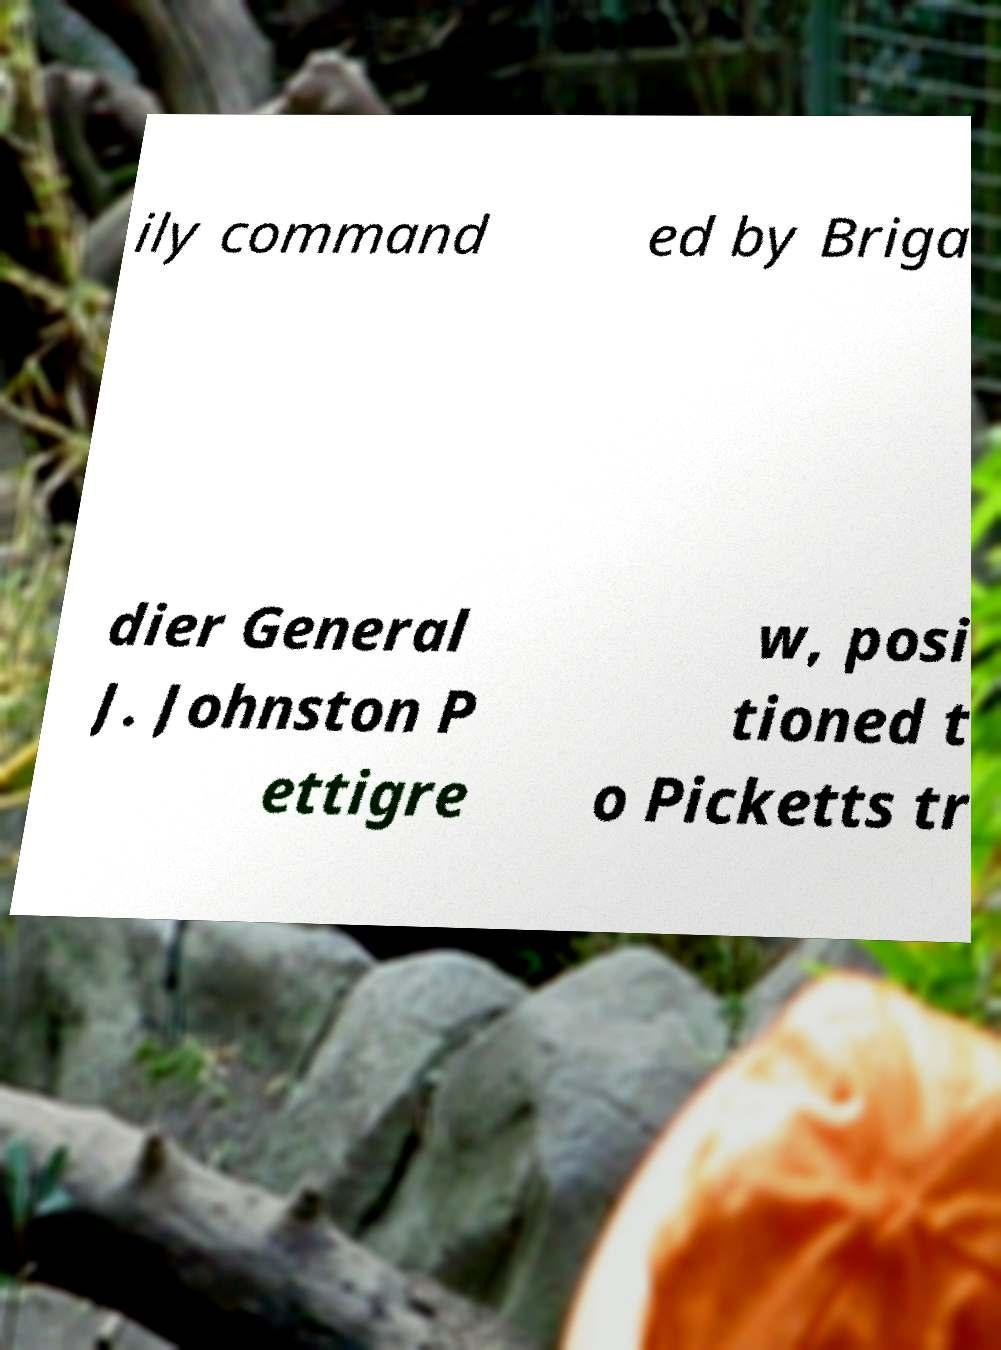Please identify and transcribe the text found in this image. ily command ed by Briga dier General J. Johnston P ettigre w, posi tioned t o Picketts tr 